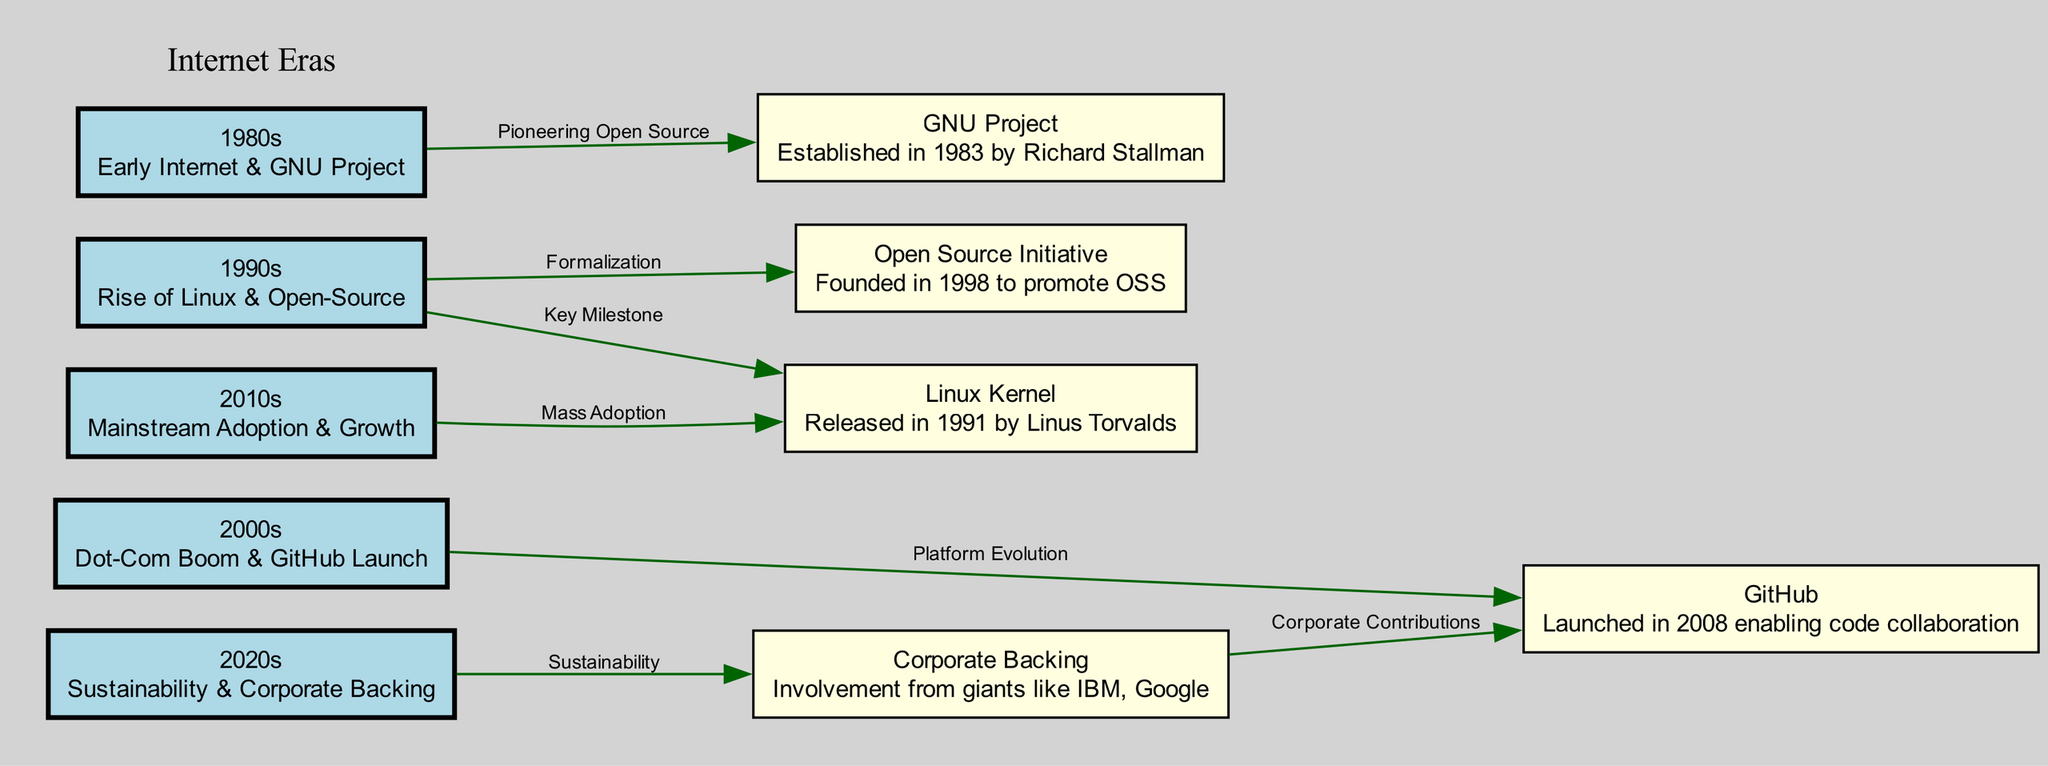What decade did the GNU Project start? The diagram shows that the GNU Project is linked to the 1980s node, which indicates the time period when it was established. Since the label of the 1980s node clearly states "Early Internet & GNU Project", we can ascertain that the GNU Project started in the 1980s.
Answer: 1980s How many internet eras are represented in the diagram? By counting the nodes labeled from the 1980s to the 2020s, we find a total of five distinct internet eras: the 1980s, 1990s, 2000s, 2010s, and 2020s. Thus, the total number is five.
Answer: 5 Which project was released in 1991? Looking at the 1990s node, it is connected to the Linux Kernel node with the label "Key Milestone". This indicates that the Linux Kernel was the significant project that was released during this decade.
Answer: Linux Kernel What major platform was launched in 2008? The diagram specifies that the 2000s is connected to the GitHub node with the label "Platform Evolution". By examining the information, it is clear that GitHub was the major platform that launched in 2008.
Answer: GitHub Which era indicates "Sustainability & Corporate Backing"? The node for the 2020s explicitly shows the description "Sustainability & Corporate Backing". By identifying the corresponding node labeled as such, we see it leads to understanding this characteristic of the 2020s.
Answer: 2020s What is the relationship between Corporate Backing and GitHub? The edge leading from the Corporate Backing node to the GitHub node is labeled "Corporate Contributions". This indicates that Corporate Backing has a direct relationship with GitHub, specifically in terms of contributions from corporate entities.
Answer: Corporate Contributions How has the Linux Kernel influenced the 2010s? The 2010s node connects to the Linux Kernel with the label "Mass Adoption", indicating that during this decade, the Linux Kernel experienced significant acceptance and usage in the open-source community.
Answer: Mass Adoption What does the Open Source Initiative signify in relation to the 1990s? The 1990s node connects to the Open Source Initiative with the label "Formalization". This conveys that during this period, the Open Source Initiative was established to formalize the movement around open-source software.
Answer: Formalization 